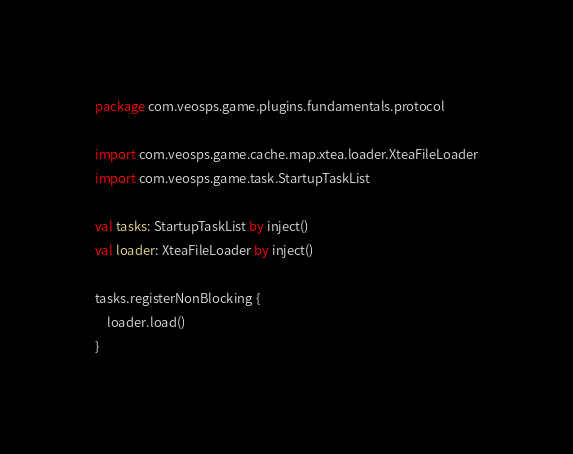<code> <loc_0><loc_0><loc_500><loc_500><_Kotlin_>package com.veosps.game.plugins.fundamentals.protocol

import com.veosps.game.cache.map.xtea.loader.XteaFileLoader
import com.veosps.game.task.StartupTaskList

val tasks: StartupTaskList by inject()
val loader: XteaFileLoader by inject()

tasks.registerNonBlocking {
    loader.load()
}
</code> 